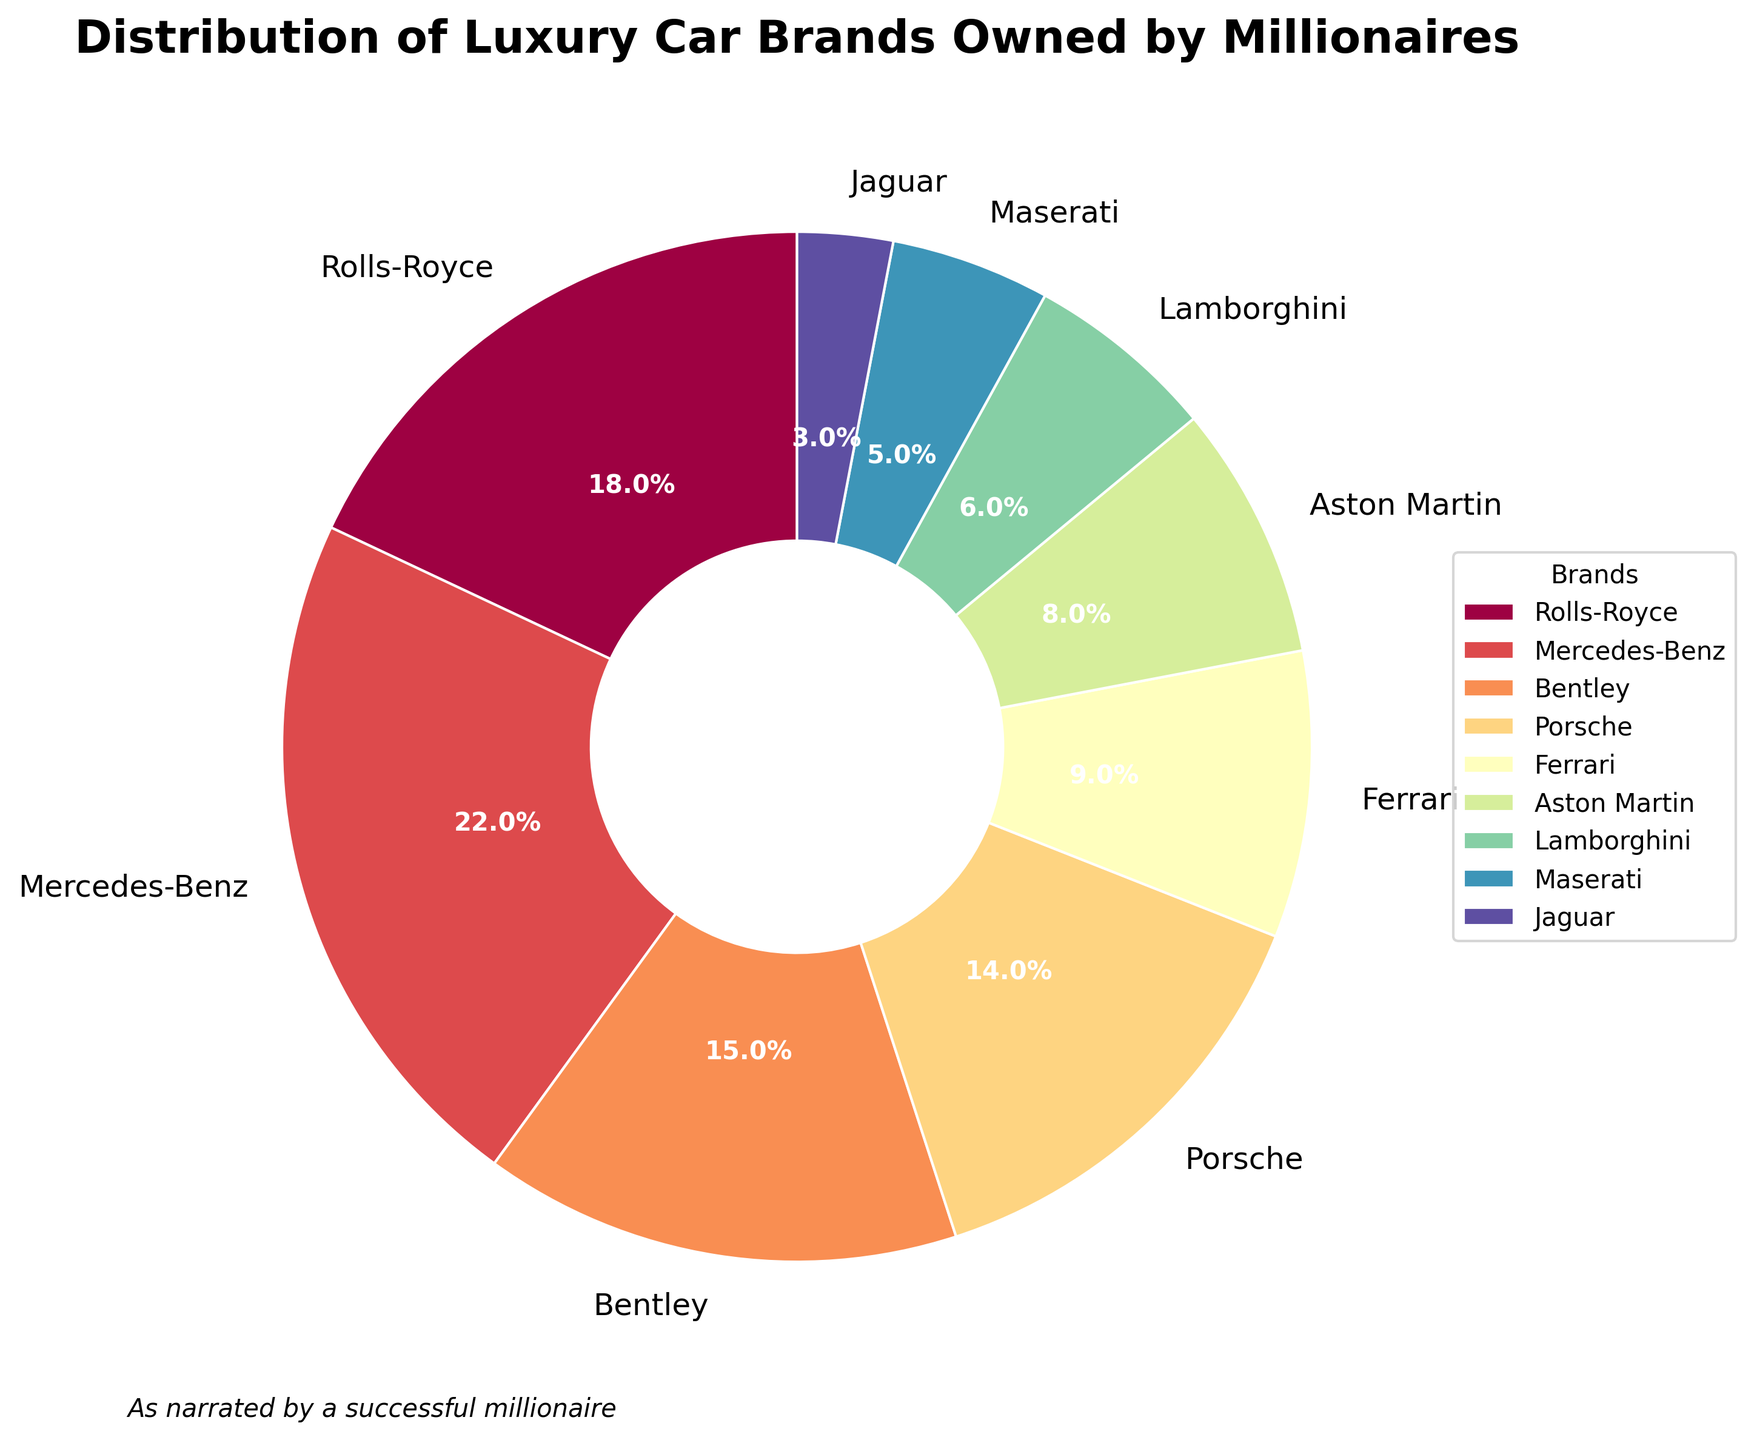What is the most popular luxury car brand among millionaires in the posh community? From the pie chart, the segment with the largest percentage represents the most popular brand. Mercedes-Benz has the largest segment, indicating that it is the most popular brand with 22%.
Answer: Mercedes-Benz How does the percentage of Ferrari owners compare to that of Lamborghini owners? To compare, locate the segments representing Ferrari and Lamborghini. Ferrari owners comprise 9% and Lamborghini owners make up 6%. Ferrari has a higher percentage than Lamborghini.
Answer: Ferrari has a higher percentage Sum the percentages of owners of Bentley, Porsche, and Ferrari. What is the total? Bentley, Porsche, and Ferrari are represented by 15%, 14%, and 9% respectively. Add these percentages: 15% + 14% + 9% = 38%.
Answer: 38% Which car brand has the least number of owners among millionaires in the posh community? Look at the smallest segment in the pie chart, which represents the brand with the least percentage. Jaguar is the smallest with 3%.
Answer: Jaguar Is the percentage of Aston Martin owners greater than or less than the percentage of Porsche owners? Check the segments for Aston Martin (8%) and Porsche (14%). The percentage of Aston Martin owners is less than that of Porsche owners.
Answer: Less than What is the combined percentage of Rolls-Royce and Maserati owners? Rolls-Royce and Maserati have percentages of 18% and 5% respectively. Add these percentages: 18% + 5% = 23%.
Answer: 23% Which two car brands together make up exactly 22% of the distribution? Look for two segments that sum to 22%. Rolls-Royce (18%) and Jaguar (3%) combine to 21%, which is incorrect. Mercedes-Benz is 22%, which is a single brand. The correct pair is not found in the pie chart.
Answer: No pair Does the distribution of Mercedes-Benz owners surpass the combined total of Lamborghini and Maserati owners? Mercedes-Benz owners make up 22%. Lamborghini and Maserati together make up 11% (6% + 5%). Since 22% is greater than 11%, Mercedes-Benz surpasses the combined total.
Answer: Yes What is the average percentage of Ferrari, Aston Martin, and Lamborghini owners? Ferrari (9%), Aston Martin (8%), and Lamborghini (6%) add up to 23%. Divide this sum by the number of brands: 23% / 3 = 7.67%.
Answer: 7.67% Compare the ownership percentages of the two least popular car brands. Which has more owners? The two least popular brands are Jaguar (3%) and Maserati (5%). Maserati has more owners than Jaguar.
Answer: Maserati 